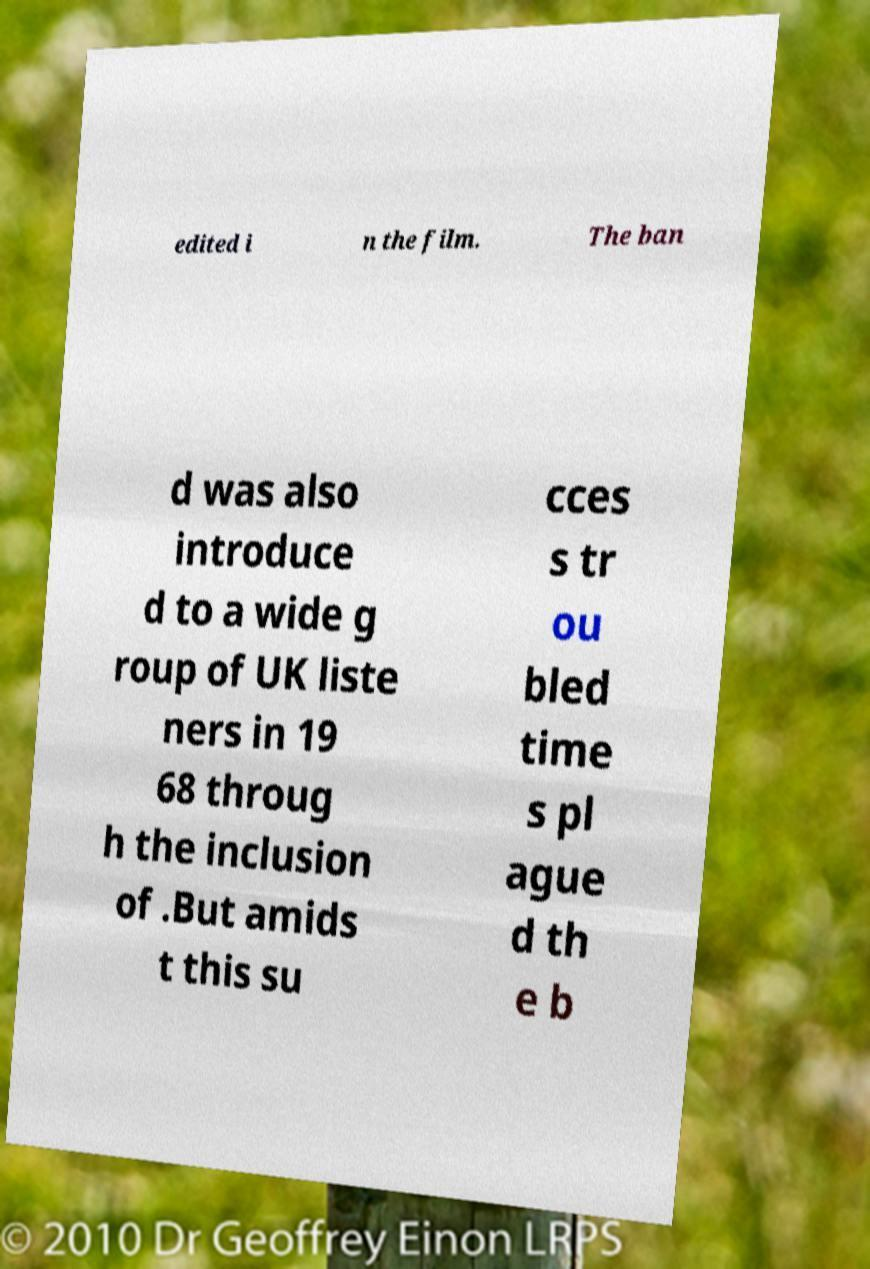There's text embedded in this image that I need extracted. Can you transcribe it verbatim? edited i n the film. The ban d was also introduce d to a wide g roup of UK liste ners in 19 68 throug h the inclusion of .But amids t this su cces s tr ou bled time s pl ague d th e b 